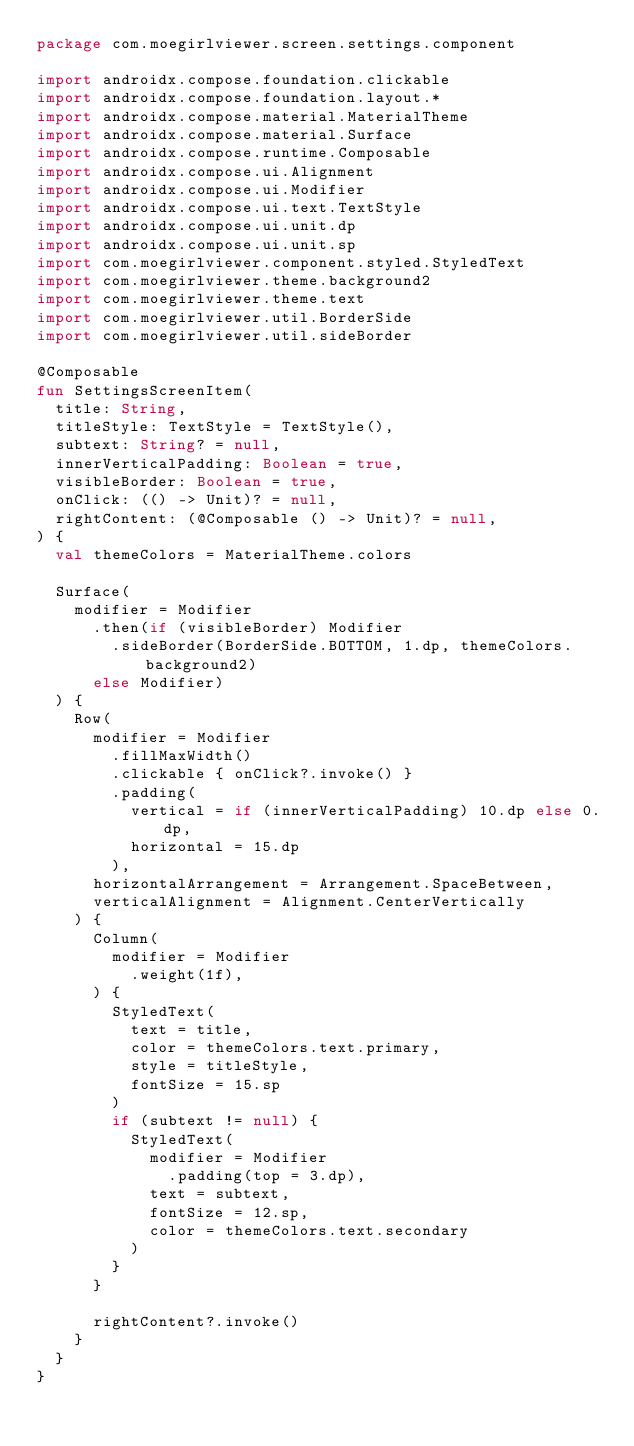Convert code to text. <code><loc_0><loc_0><loc_500><loc_500><_Kotlin_>package com.moegirlviewer.screen.settings.component

import androidx.compose.foundation.clickable
import androidx.compose.foundation.layout.*
import androidx.compose.material.MaterialTheme
import androidx.compose.material.Surface
import androidx.compose.runtime.Composable
import androidx.compose.ui.Alignment
import androidx.compose.ui.Modifier
import androidx.compose.ui.text.TextStyle
import androidx.compose.ui.unit.dp
import androidx.compose.ui.unit.sp
import com.moegirlviewer.component.styled.StyledText
import com.moegirlviewer.theme.background2
import com.moegirlviewer.theme.text
import com.moegirlviewer.util.BorderSide
import com.moegirlviewer.util.sideBorder

@Composable
fun SettingsScreenItem(
  title: String,
  titleStyle: TextStyle = TextStyle(),
  subtext: String? = null,
  innerVerticalPadding: Boolean = true,
  visibleBorder: Boolean = true,
  onClick: (() -> Unit)? = null,
  rightContent: (@Composable () -> Unit)? = null,
) {
  val themeColors = MaterialTheme.colors

  Surface(
    modifier = Modifier
      .then(if (visibleBorder) Modifier
        .sideBorder(BorderSide.BOTTOM, 1.dp, themeColors.background2)
      else Modifier)
  ) {
    Row(
      modifier = Modifier
        .fillMaxWidth()
        .clickable { onClick?.invoke() }
        .padding(
          vertical = if (innerVerticalPadding) 10.dp else 0.dp,
          horizontal = 15.dp
        ),
      horizontalArrangement = Arrangement.SpaceBetween,
      verticalAlignment = Alignment.CenterVertically
    ) {
      Column(
        modifier = Modifier
          .weight(1f),
      ) {
        StyledText(
          text = title,
          color = themeColors.text.primary,
          style = titleStyle,
          fontSize = 15.sp
        )
        if (subtext != null) {
          StyledText(
            modifier = Modifier
              .padding(top = 3.dp),
            text = subtext,
            fontSize = 12.sp,
            color = themeColors.text.secondary
          )
        }
      }

      rightContent?.invoke()
    }
  }
}</code> 